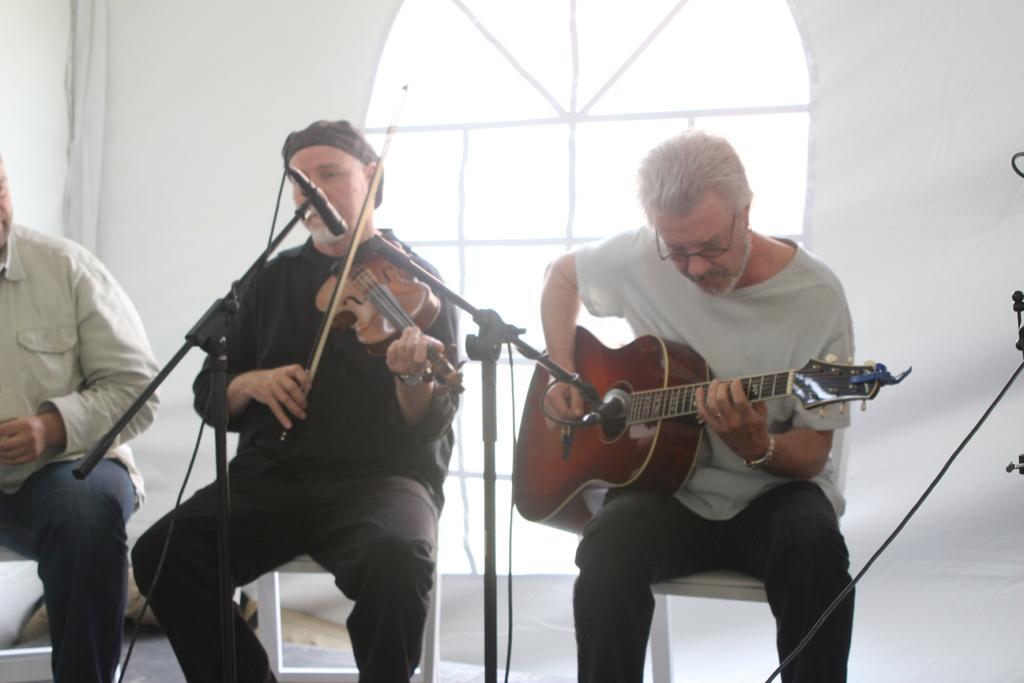How would you summarize this image in a sentence or two? The person wearing T-shirt is playing guitar in front of a mic and the person beside him is playing violin in front of a mic and the person in the left corner is sitting. 